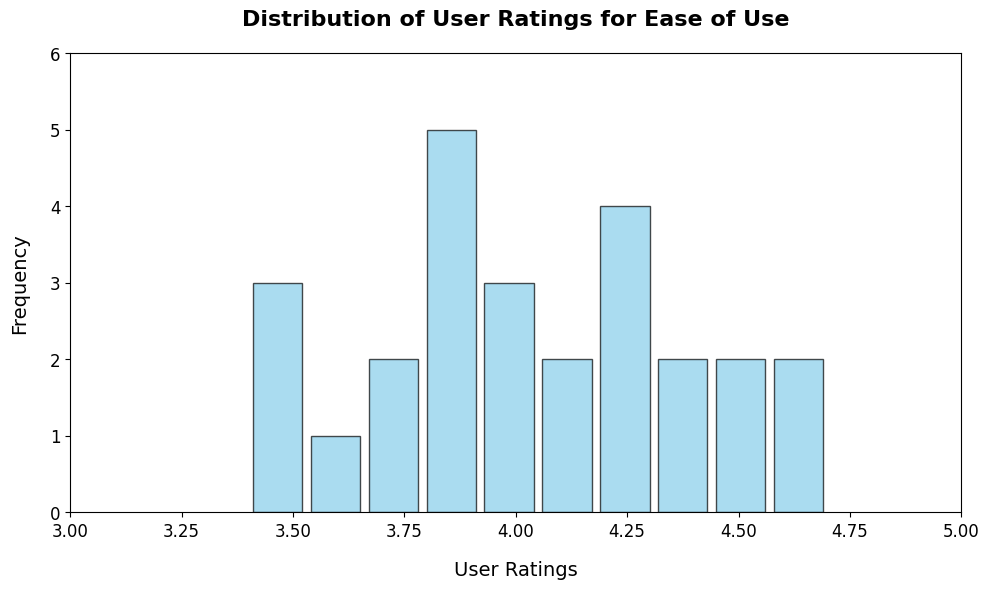Which range has the highest frequency in user ratings? By observing the histogram bars, identify the bar with the highest height, which indicates the range with the greatest frequency.
Answer: The range 4.0 to 4.2 How many models have a user rating of ease of use between 3.4 and 3.6? Count the number of models falling within the bin/bars representing 3.4 to 3.6 from the visual data.
Answer: 3 models What is the median user rating for the smartphone models in the histogram? The median is the middle value of the dataset when ordered. Since there are 26 values, the median is the average of the 13th and 14th values when sorted.
Answer: Approximately 4.0 Are there more models with a rating above 4.0 or below 4.0? Compare the counts of models in bins above and below 4.0. Visually sum the heights of bars representing ratings greater than 4.0 and those less than 4.0.
Answer: More models above 4.0 Identify the range which has the lowest frequency of user ratings Look for the bar with the shortest height which reflects the range with the least frequency.
Answer: The range 3.4 to 3.6 What is the average user rating for ease of use among the smartphone models? Sum all user ratings and divide by the total number of models (26). This requires numerical calculation beyond just the histogram but can be reasoned visually by averaging the central tendency of the height of the bars.
Answer: Approximately 4.0 Which range of user ratings has the same frequency? Identify the ranges with bars having the same height visually.
Answer: Ranges 3.6 to 3.8 and 4.4 to 4.6 How many models received a user rating equal to or above 4.5? Count the number of models in the bins corresponding to 4.5 and above from visual information.
Answer: 3 models 